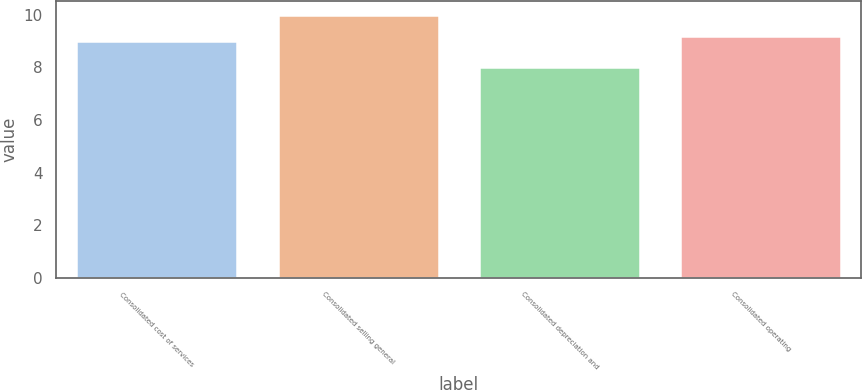<chart> <loc_0><loc_0><loc_500><loc_500><bar_chart><fcel>Consolidated cost of services<fcel>Consolidated selling general<fcel>Consolidated depreciation and<fcel>Consolidated operating<nl><fcel>9<fcel>10<fcel>8<fcel>9.2<nl></chart> 